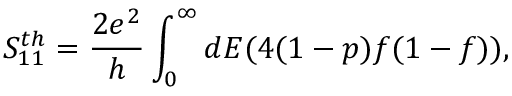<formula> <loc_0><loc_0><loc_500><loc_500>{ S _ { 1 1 } ^ { t h } = \frac { 2 e ^ { 2 } } { h } \int _ { 0 } ^ { \infty } d E ( 4 ( 1 - p ) f ( 1 - f ) ) , }</formula> 